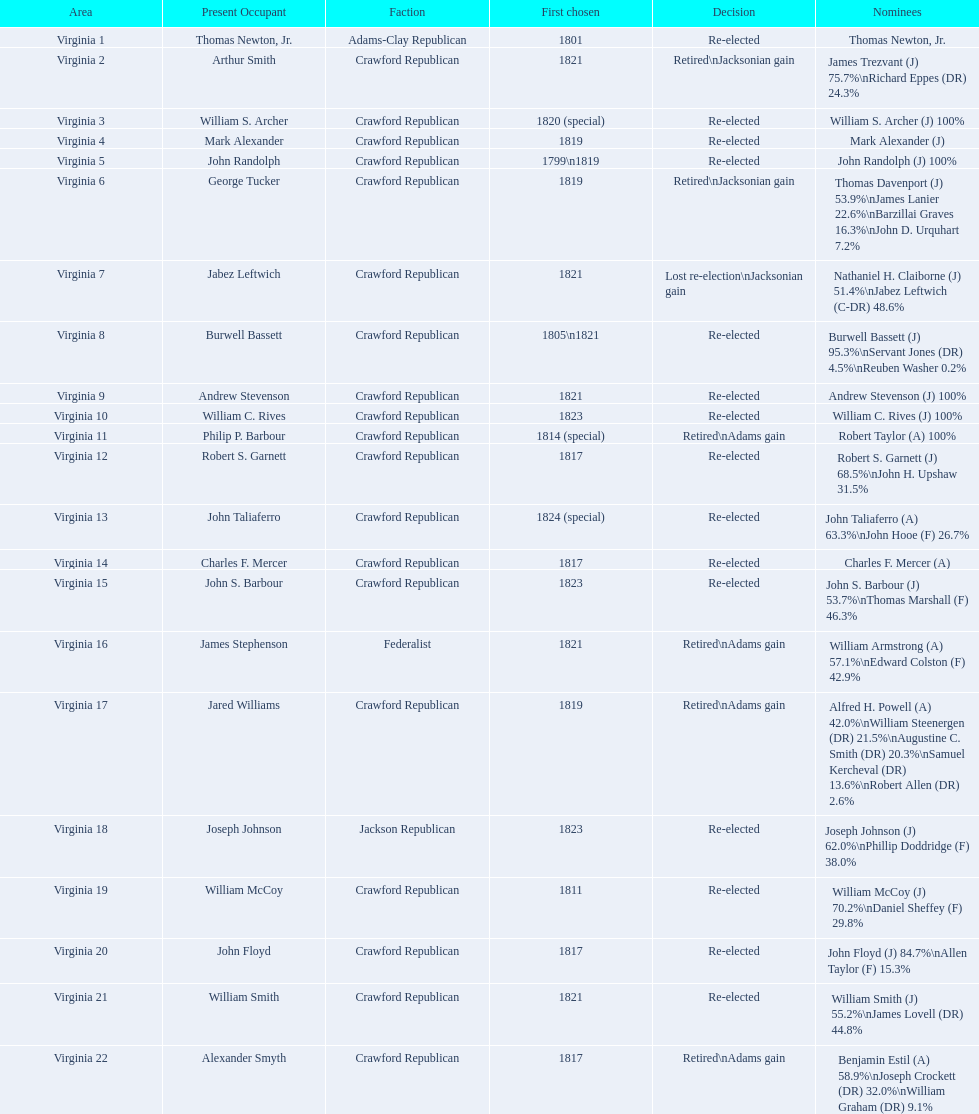What party is a crawford republican? Crawford Republican, Crawford Republican, Crawford Republican, Crawford Republican, Crawford Republican, Crawford Republican, Crawford Republican, Crawford Republican, Crawford Republican, Crawford Republican, Crawford Republican, Crawford Republican, Crawford Republican, Crawford Republican, Crawford Republican, Crawford Republican, Crawford Republican, Crawford Republican, Crawford Republican. What candidates have over 76%? James Trezvant (J) 75.7%\nRichard Eppes (DR) 24.3%, William S. Archer (J) 100%, John Randolph (J) 100%, Burwell Bassett (J) 95.3%\nServant Jones (DR) 4.5%\nReuben Washer 0.2%, Andrew Stevenson (J) 100%, William C. Rives (J) 100%, Robert Taylor (A) 100%, John Floyd (J) 84.7%\nAllen Taylor (F) 15.3%. Which result was retired jacksonian gain? Retired\nJacksonian gain. Who was the incumbent? Arthur Smith. 